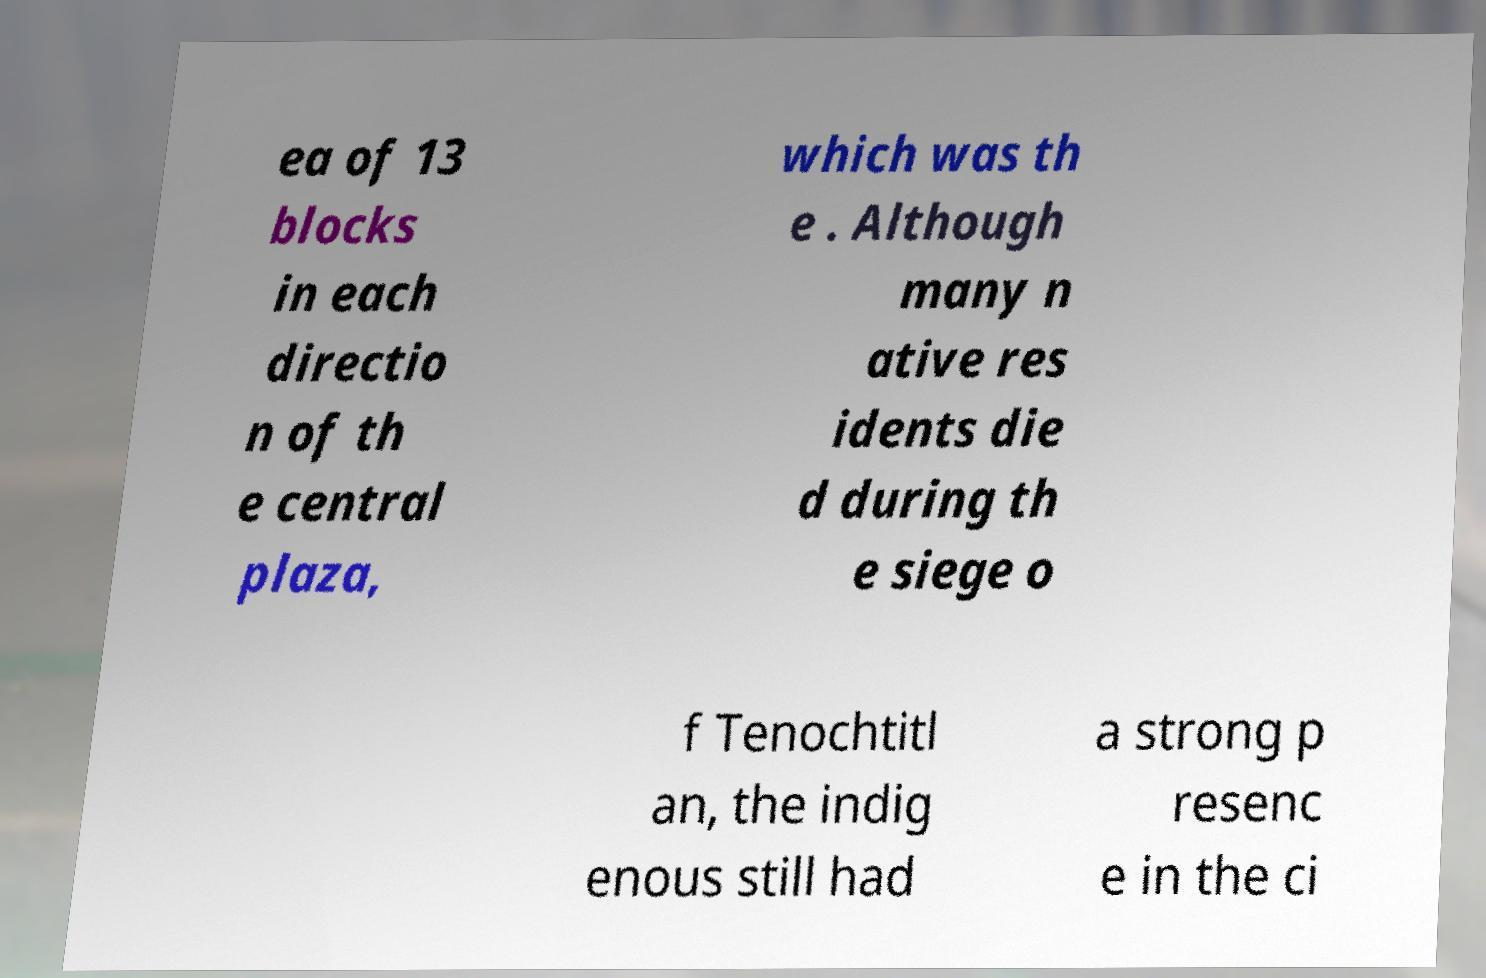There's text embedded in this image that I need extracted. Can you transcribe it verbatim? ea of 13 blocks in each directio n of th e central plaza, which was th e . Although many n ative res idents die d during th e siege o f Tenochtitl an, the indig enous still had a strong p resenc e in the ci 